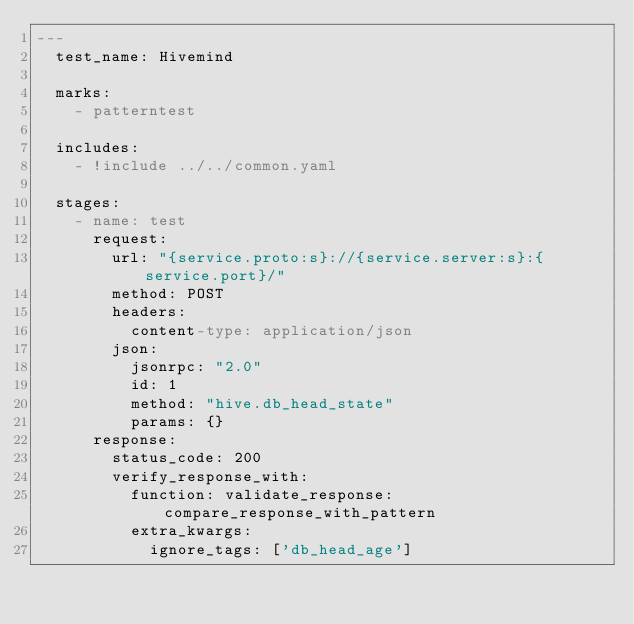<code> <loc_0><loc_0><loc_500><loc_500><_YAML_>---
  test_name: Hivemind

  marks:
    - patterntest

  includes:
    - !include ../../common.yaml

  stages:
    - name: test
      request:
        url: "{service.proto:s}://{service.server:s}:{service.port}/"
        method: POST
        headers:
          content-type: application/json
        json:
          jsonrpc: "2.0"
          id: 1
          method: "hive.db_head_state"
          params: {}
      response:
        status_code: 200
        verify_response_with:
          function: validate_response:compare_response_with_pattern
          extra_kwargs:
            ignore_tags: ['db_head_age']
</code> 